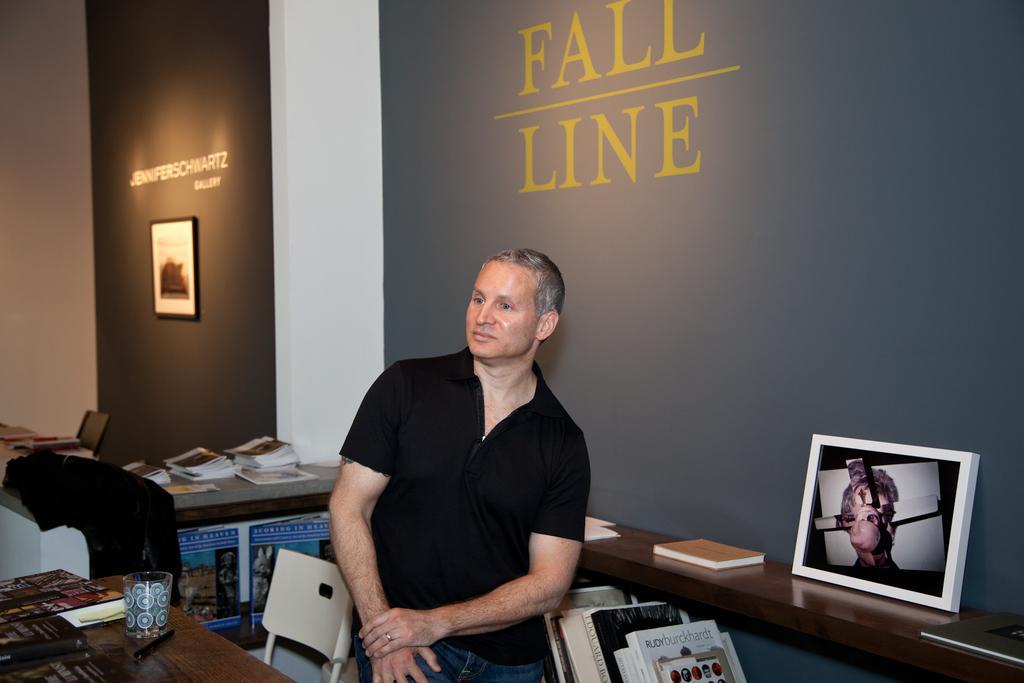Describe this image in one or two sentences. In this picture there is a man standing in the middle. There are few books in the shelf and a frame. There is a glass, pen ,books on the table. There is a chair. There is a black jacket on the desk. There is a frame on the wall. 